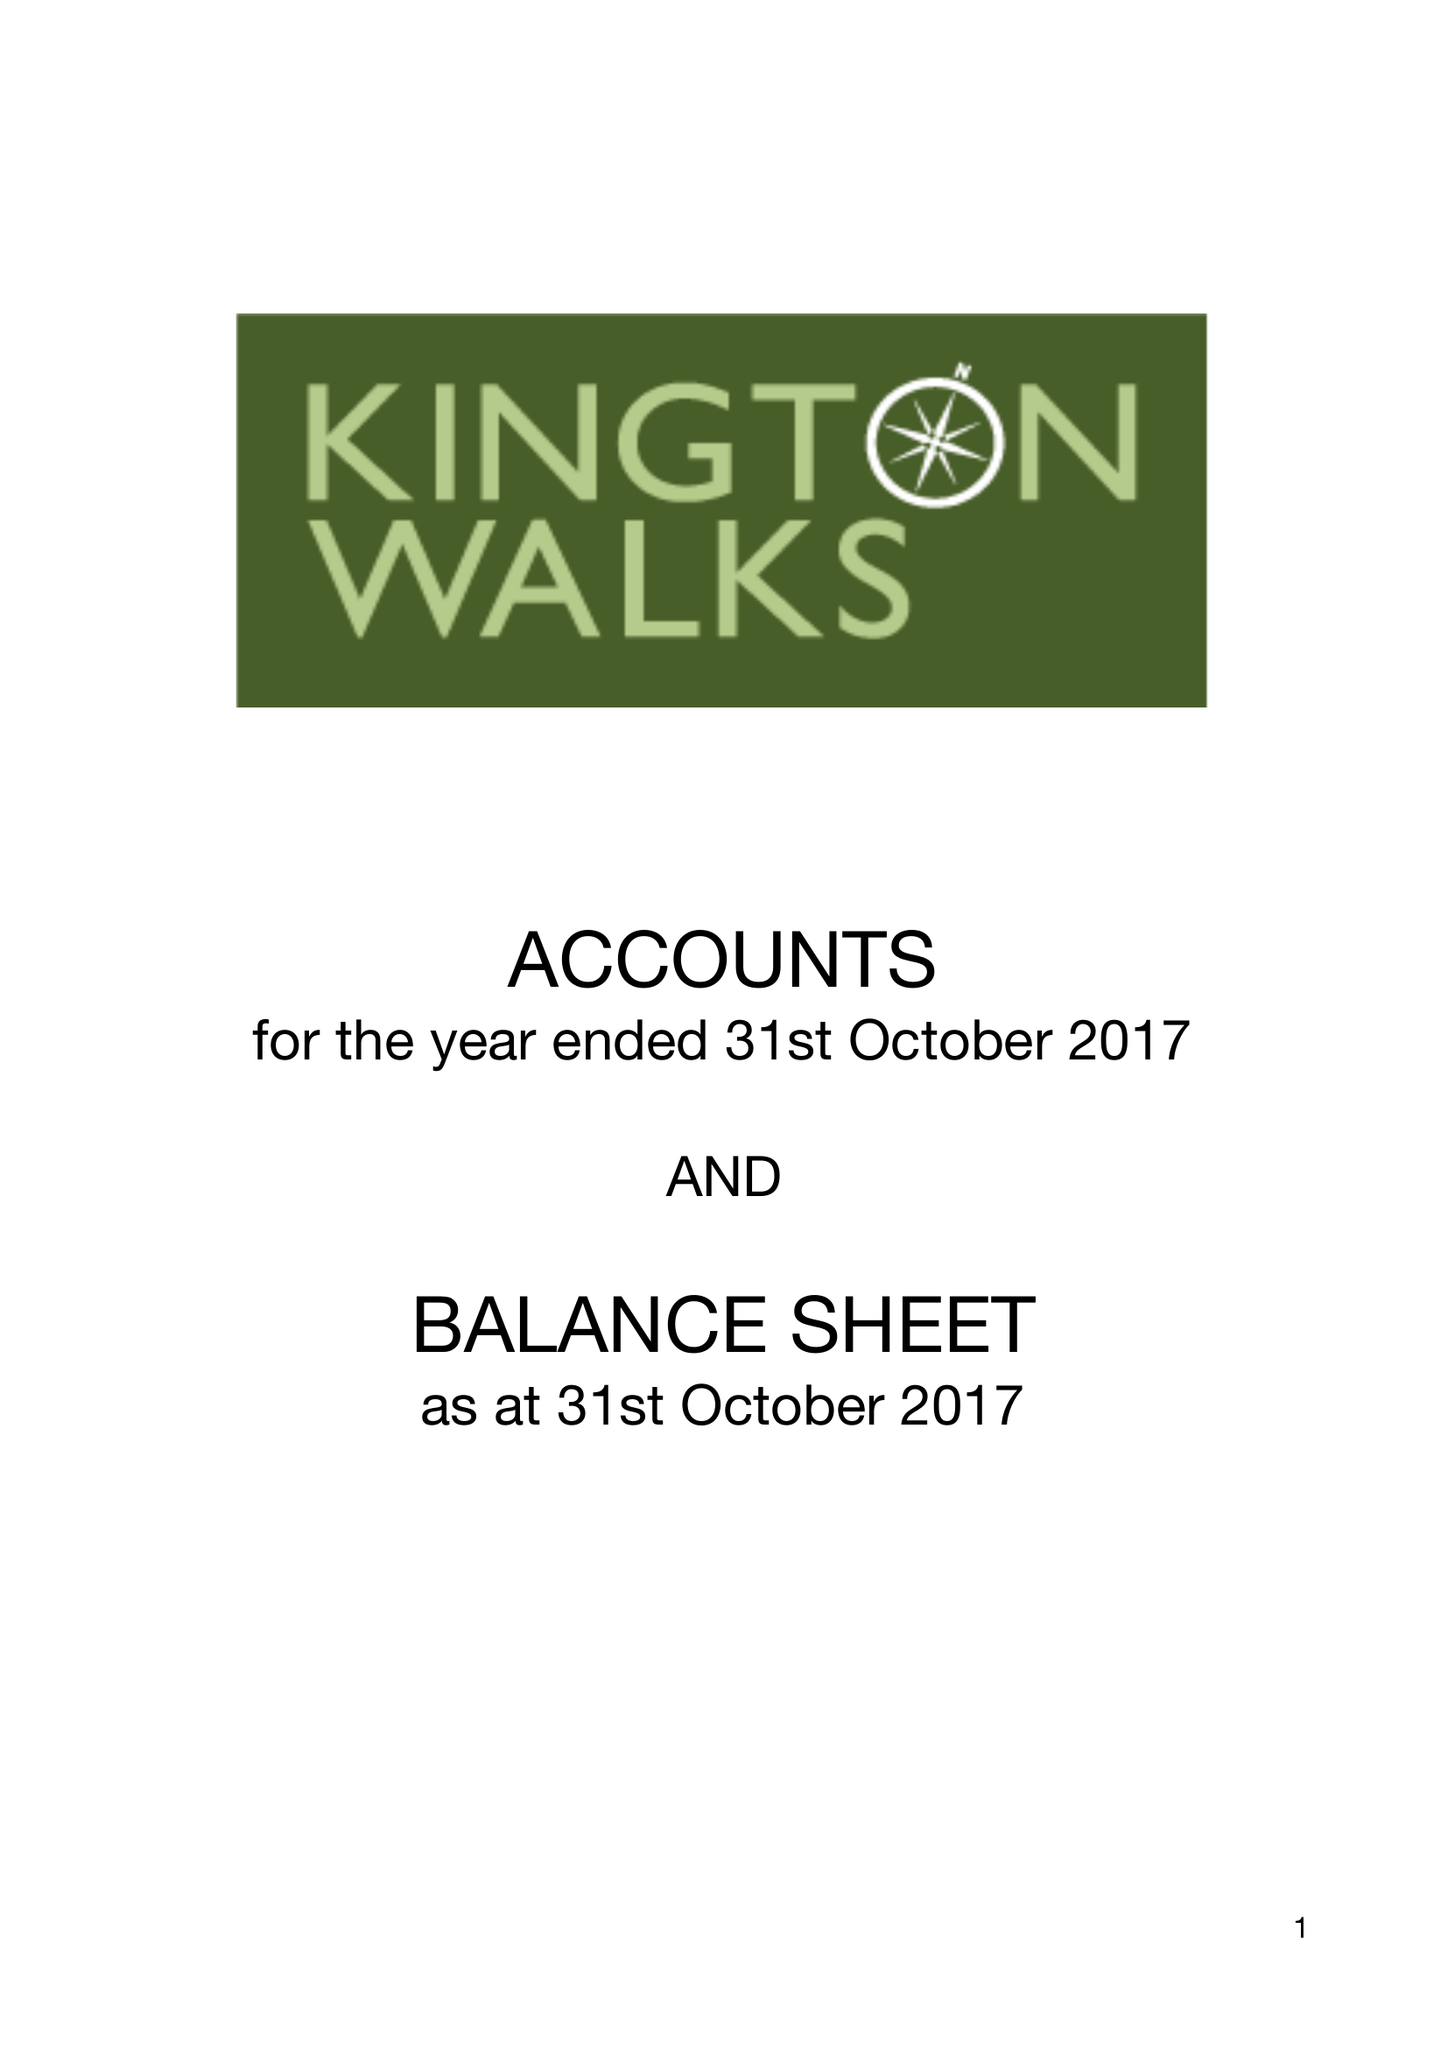What is the value for the charity_number?
Answer the question using a single word or phrase. 1172022 